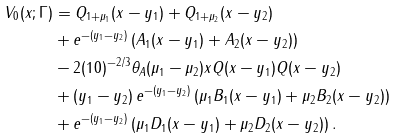<formula> <loc_0><loc_0><loc_500><loc_500>V _ { 0 } ( x ; \Gamma ) & = Q _ { 1 + \mu _ { 1 } } ( x - y _ { 1 } ) + Q _ { 1 + \mu _ { 2 } } ( x - y _ { 2 } ) \\ & + e ^ { - ( y _ { 1 } - y _ { 2 } ) } \left ( A _ { 1 } ( x - y _ { 1 } ) + A _ { 2 } ( x - y _ { 2 } ) \right ) \\ & - 2 ( 1 0 ) ^ { - 2 / 3 } \theta _ { A } ( \mu _ { 1 } - \mu _ { 2 } ) x Q ( x - y _ { 1 } ) Q ( x - y _ { 2 } ) \\ & + ( y _ { 1 } - y _ { 2 } ) \, e ^ { - ( y _ { 1 } - y _ { 2 } ) } \left ( \mu _ { 1 } B _ { 1 } ( x - y _ { 1 } ) + \mu _ { 2 } B _ { 2 } ( x - y _ { 2 } ) \right ) \\ & + e ^ { - ( y _ { 1 } - y _ { 2 } ) } \left ( \mu _ { 1 } D _ { 1 } ( x - y _ { 1 } ) + \mu _ { 2 } D _ { 2 } ( x - y _ { 2 } ) \right ) .</formula> 